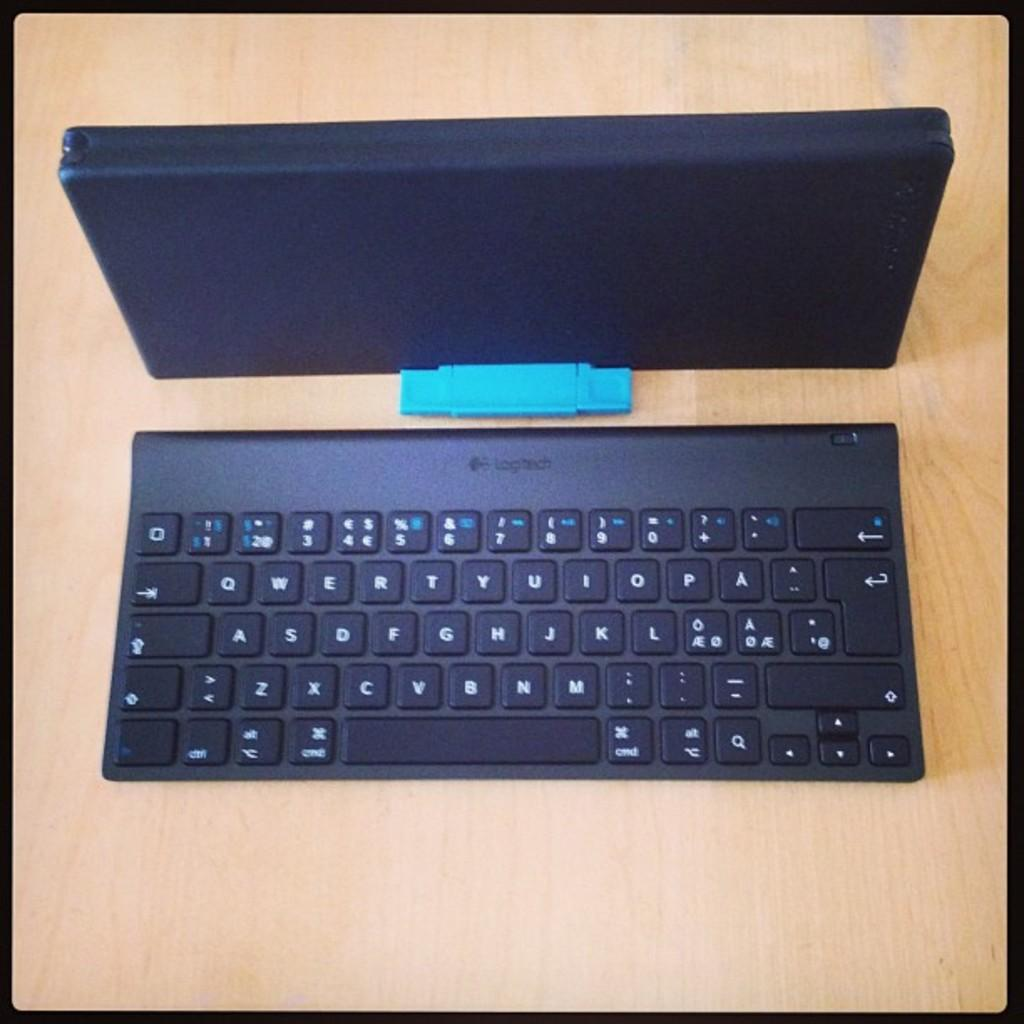<image>
Render a clear and concise summary of the photo. A Logitech black keyboard sitting on a desk. 